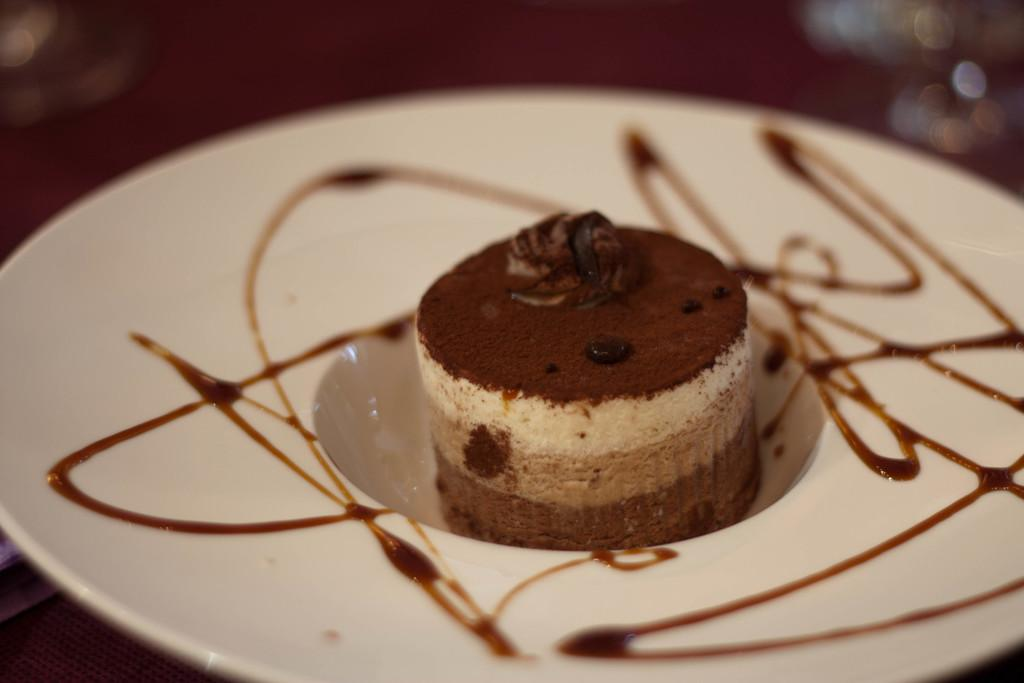What is on the plate in the image? There is a cake on the plate in the image. What is on top of the cake? There is cream on the cake. Can you describe the background of the image? The background of the image is blurry. What type of cabbage is being used in the operation depicted in the image? There is no operation or cabbage present in the image; it features a plate with a cake and cream. 